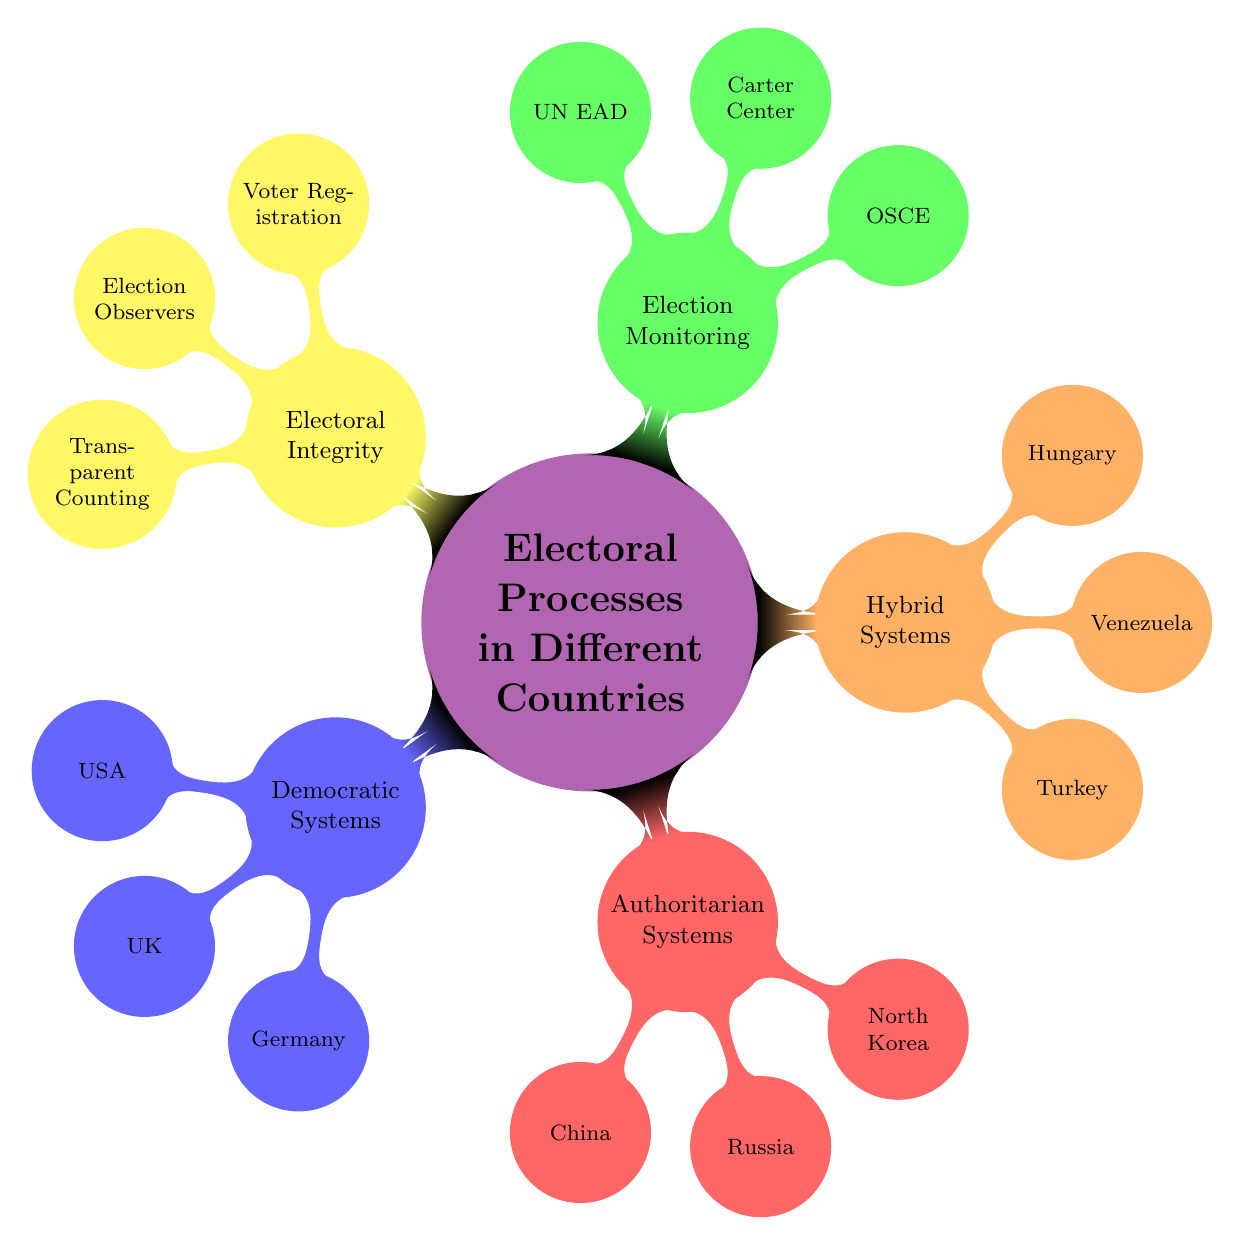What are the three categories of electoral systems shown in the diagram? The diagram shows three main categories: Democratic Systems, Authoritarian Systems, and Hybrid Systems. Each of these categories encompasses different countries and their electoral characteristics.
Answer: Democratic Systems, Authoritarian Systems, Hybrid Systems Which country uses the "Electoral College" method? The United States is the country that uses the "Electoral College" election method as indicated in the diagram.
Answer: United States How many examples are provided under "Hybrid Systems"? The diagram lists three countries under Hybrid Systems: Turkey, Venezuela, and Hungary. Thus, the total number of examples is three.
Answer: 3 What election method is used in China? The election method used in China, as stated in the diagram, is "Indirect, Controlled by CCP." This reflects the nature of their political system.
Answer: Indirect, Controlled by CCP Which organization is one of the entities involved in election monitoring? The OSCE (Organization for Security and Co-operation in Europe) is listed in the diagram as one of the entities involved in election monitoring.
Answer: OSCE What are the components of electoral integrity mentioned in the diagram? The components of electoral integrity stated in the diagram are Voter Registration, Election Observers, and Transparent Counting. These elements play critical roles in maintaining electoral credibility.
Answer: Voter Registration, Election Observers, Transparent Counting Which system is associated with North Korea? North Korea is associated with the "Single-Party with Supreme Leader" system as depicted in the diagram, which emphasizes the nature of its political structure.
Answer: Single-Party with Supreme Leader How does Turkey's electoral method reflect concerns of fairness? Turkey uses a "Majoritarian" system, but the diagram specifies that there are "Concerns of Fairness," indicating that the elections are perceived as potentially compromised despite being democratic in nature.
Answer: Majoritarian, Concerns of Fairness 